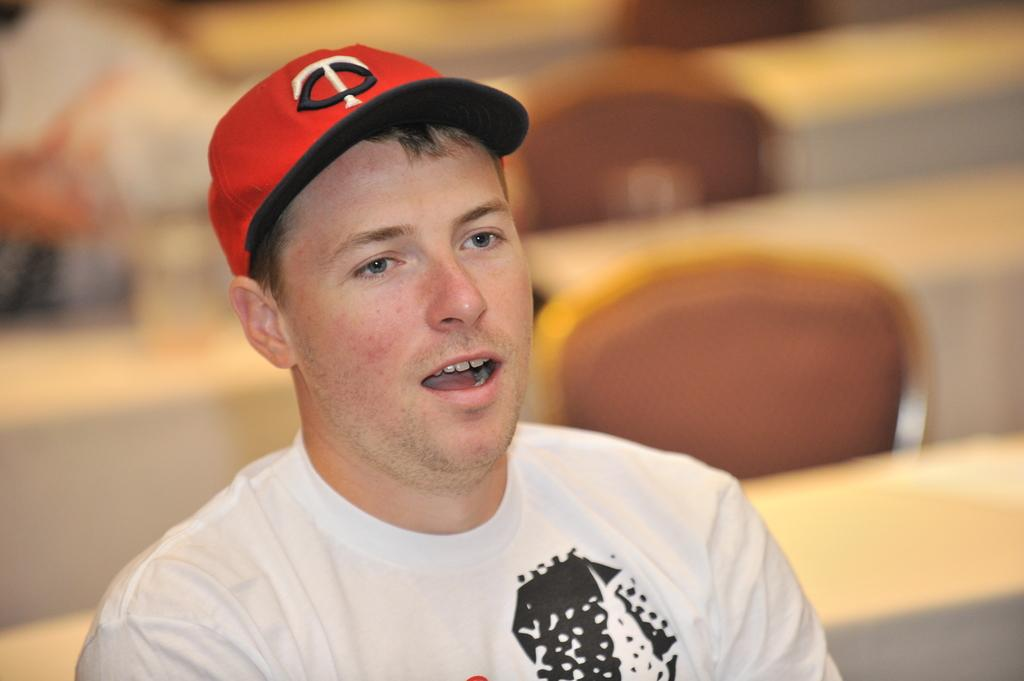What is the main subject of the image? There is a man in the image. What is the man wearing on his head? The man is wearing a cap. What type of furniture can be seen in the background of the image? There are tables and chairs in the background of the image. Can you see any pigs in the cellar in the image? There is no cellar or pigs present in the image. 